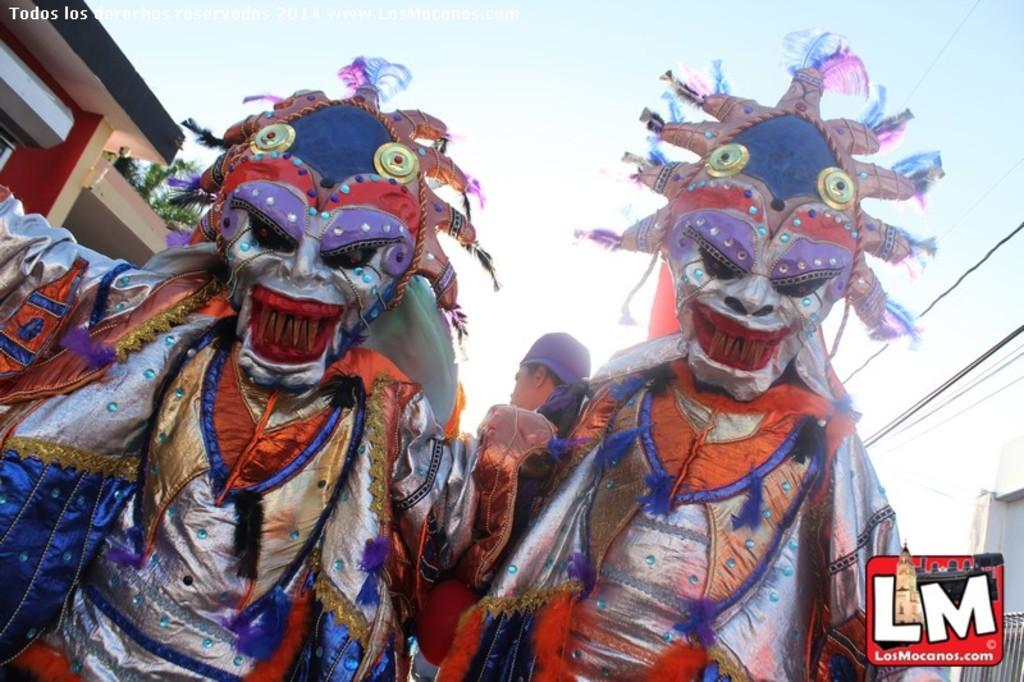What can be seen in the image regarding the people? There is a group of people in costumes in the image. What is the logo associated with in the image? The presence of the logo is not specified, so we cannot determine its association. What is visible in the background of the image? There is a house, trees, wires, and the sky visible in the background of the image. Can you describe the time of day the image appears to be taken? The image appears to be taken during the day, as the sky is visible. How many cherries are being shaken off the tree in the image? There are no cherries or trees present in the image, so it is not possible to answer this question. 